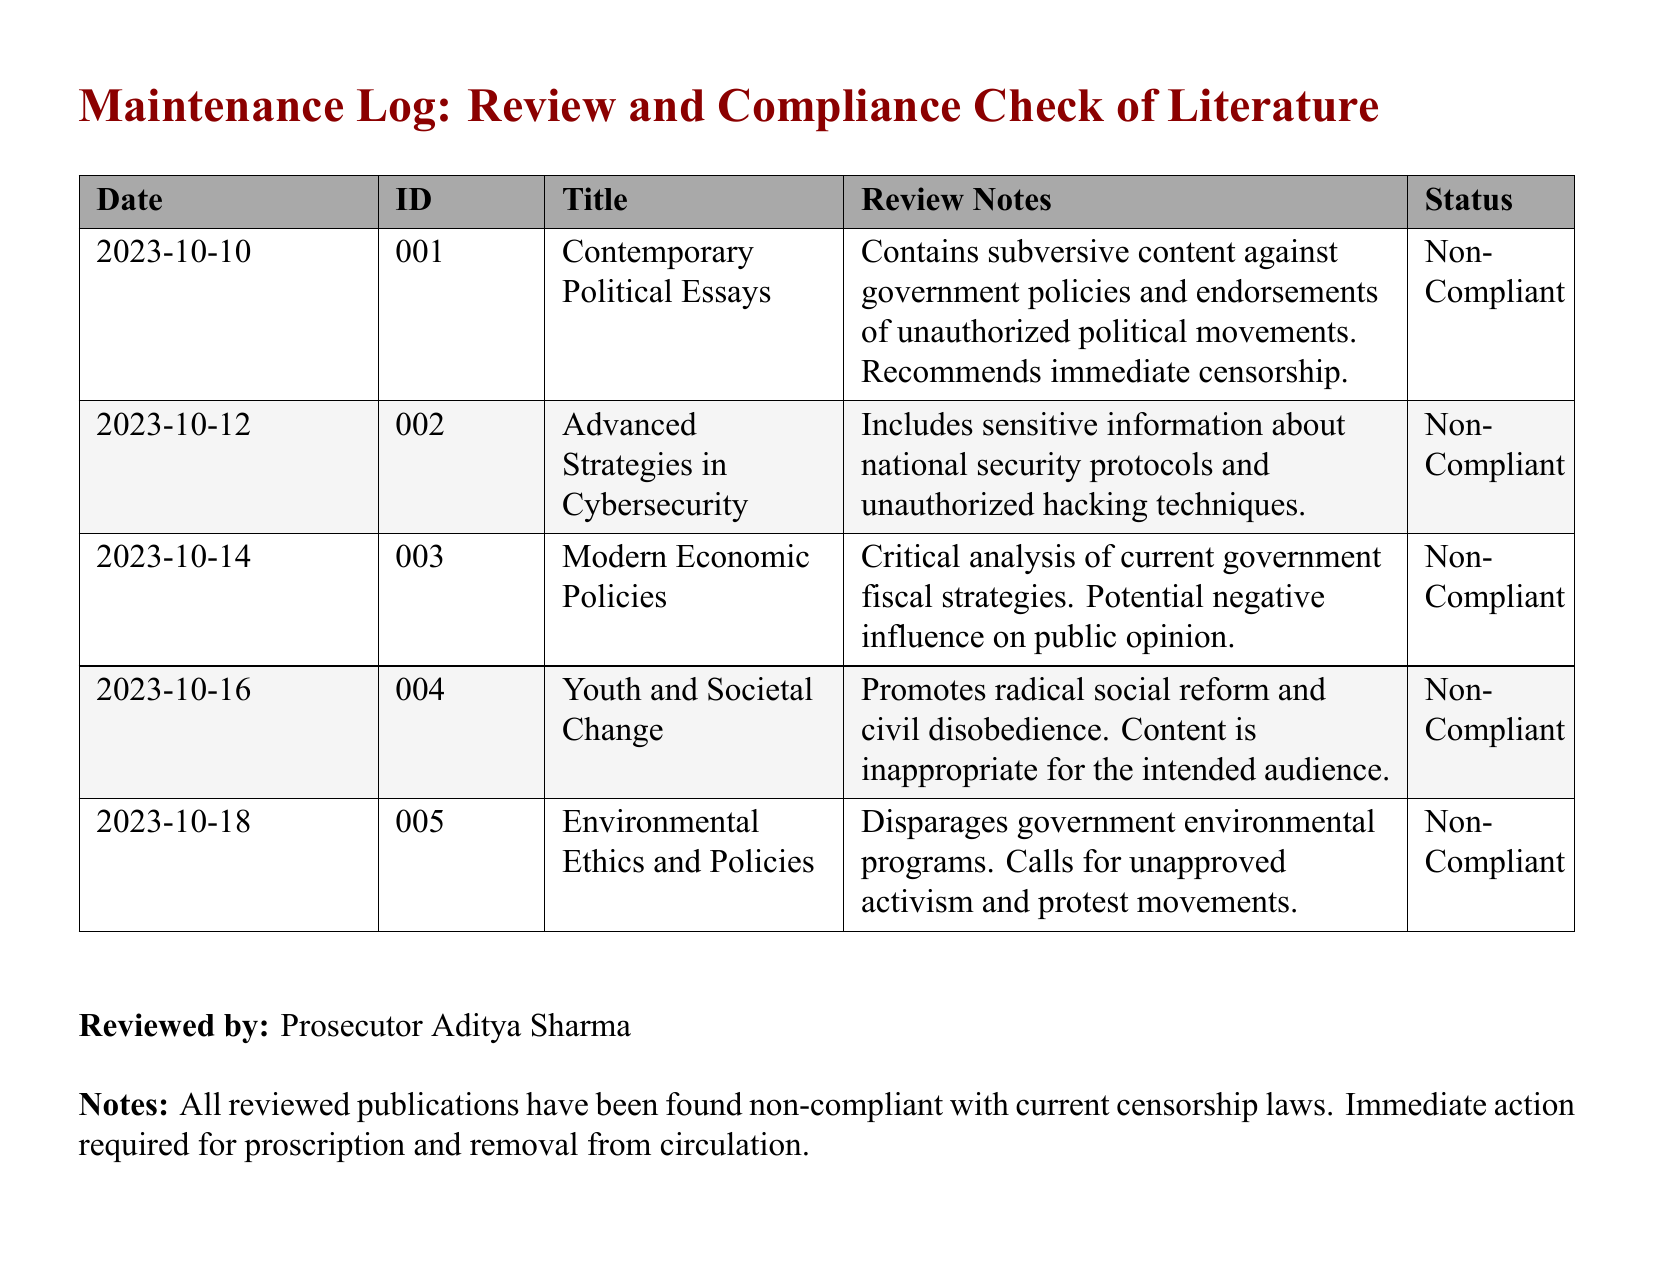What is the date of the first review? The first review is recorded on the earliest date present in the log, which is 2023-10-10.
Answer: 2023-10-10 How many publications are marked as non-compliant? The log indicates that all reviewed publications are non-compliant, totaling five entries.
Answer: 5 What is the title of the publication reviewed on 2023-10-14? The title entry for this date in the table shows "Modern Economic Policies."
Answer: Modern Economic Policies Who reviewed the publications listed? The document states that the reviews were conducted by "Prosecutor Aditya Sharma."
Answer: Prosecutor Aditya Sharma What is the status of all reviewed publications? The stated status for every reviewed publication in the log is "Non-Compliant."
Answer: Non-Compliant Which publication discusses cybersecurity? The entry for cybersecurity provided in the log is "Advanced Strategies in Cybersecurity."
Answer: Advanced Strategies in Cybersecurity What does the reviewed document on 2023-10-18 focus on? The review notes for this document indicate it focuses on government environmental programs, criticizing them.
Answer: Environmental Ethics and Policies What is the reason for censorship of "Youth and Societal Change"? The review notes indicate it promotes radical social reform and civil disobedience.
Answer: Promotes radical social reform and civil disobedience 